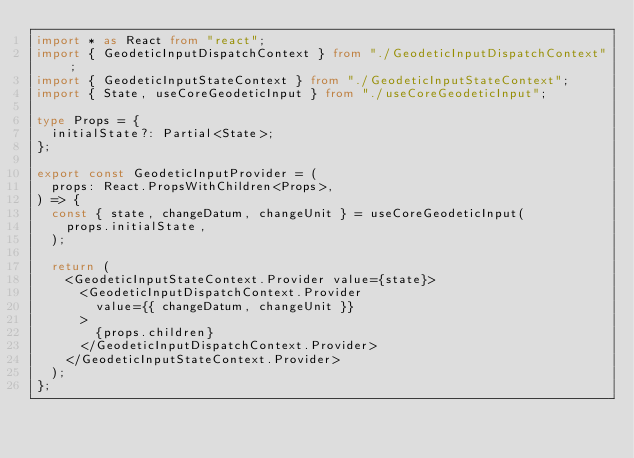<code> <loc_0><loc_0><loc_500><loc_500><_TypeScript_>import * as React from "react";
import { GeodeticInputDispatchContext } from "./GeodeticInputDispatchContext";
import { GeodeticInputStateContext } from "./GeodeticInputStateContext";
import { State, useCoreGeodeticInput } from "./useCoreGeodeticInput";

type Props = {
  initialState?: Partial<State>;
};

export const GeodeticInputProvider = (
  props: React.PropsWithChildren<Props>,
) => {
  const { state, changeDatum, changeUnit } = useCoreGeodeticInput(
    props.initialState,
  );

  return (
    <GeodeticInputStateContext.Provider value={state}>
      <GeodeticInputDispatchContext.Provider
        value={{ changeDatum, changeUnit }}
      >
        {props.children}
      </GeodeticInputDispatchContext.Provider>
    </GeodeticInputStateContext.Provider>
  );
};
</code> 